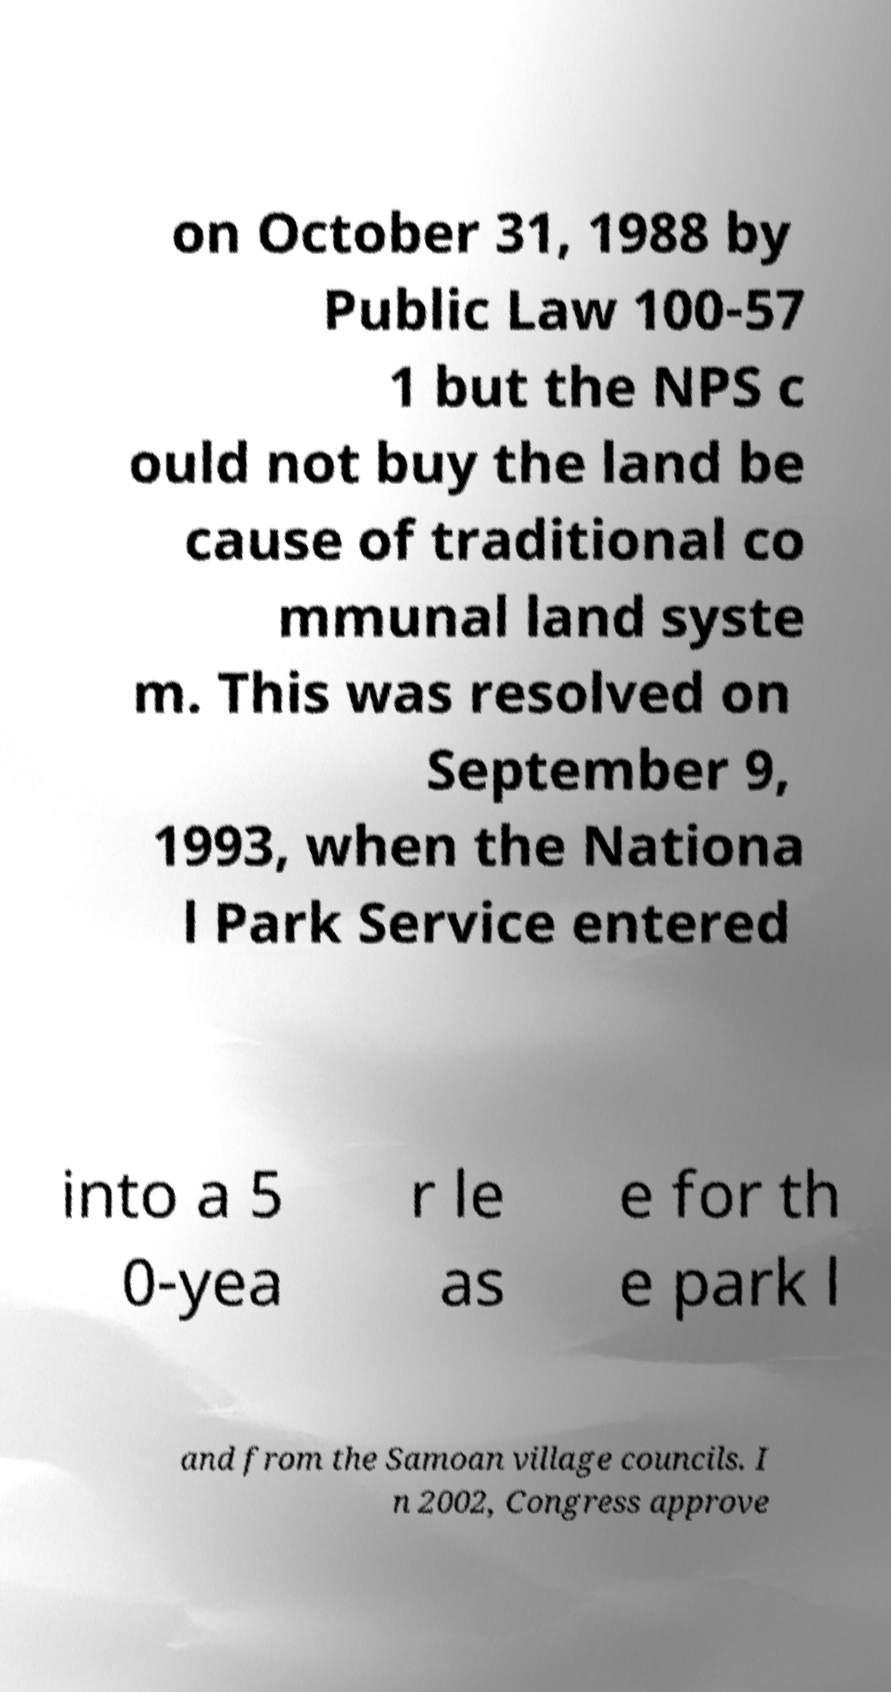Please read and relay the text visible in this image. What does it say? on October 31, 1988 by Public Law 100-57 1 but the NPS c ould not buy the land be cause of traditional co mmunal land syste m. This was resolved on September 9, 1993, when the Nationa l Park Service entered into a 5 0-yea r le as e for th e park l and from the Samoan village councils. I n 2002, Congress approve 